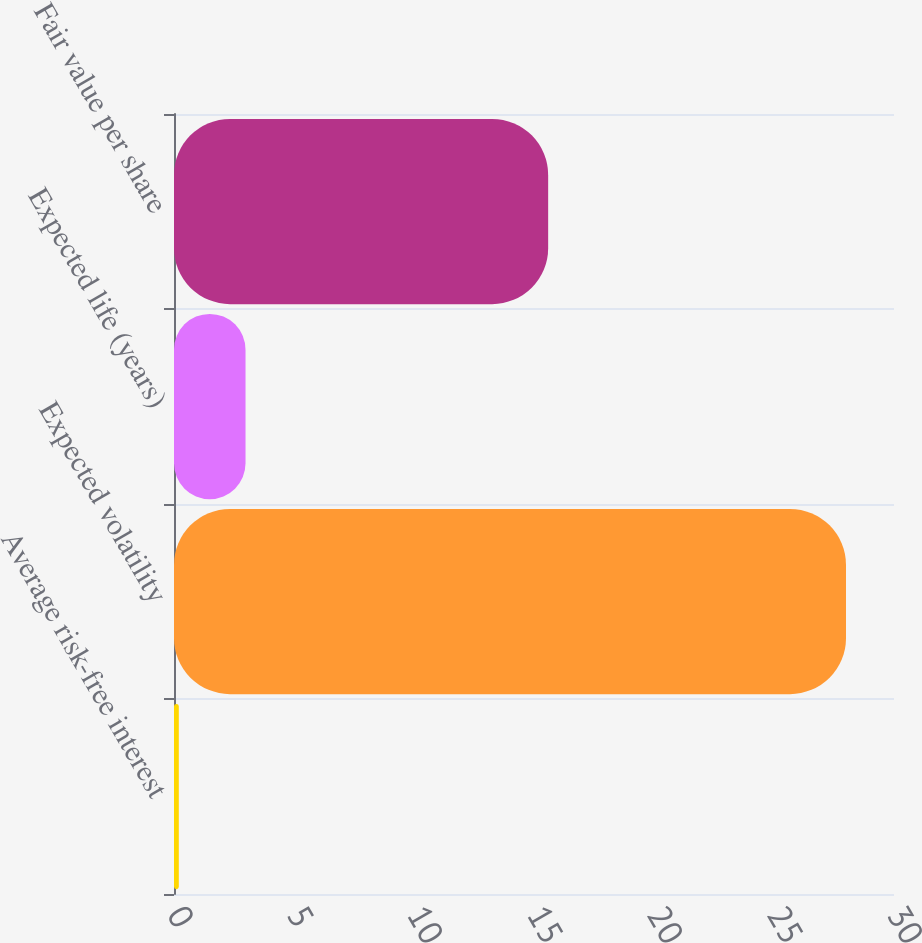<chart> <loc_0><loc_0><loc_500><loc_500><bar_chart><fcel>Average risk-free interest<fcel>Expected volatility<fcel>Expected life (years)<fcel>Fair value per share<nl><fcel>0.2<fcel>28<fcel>2.98<fcel>15.59<nl></chart> 